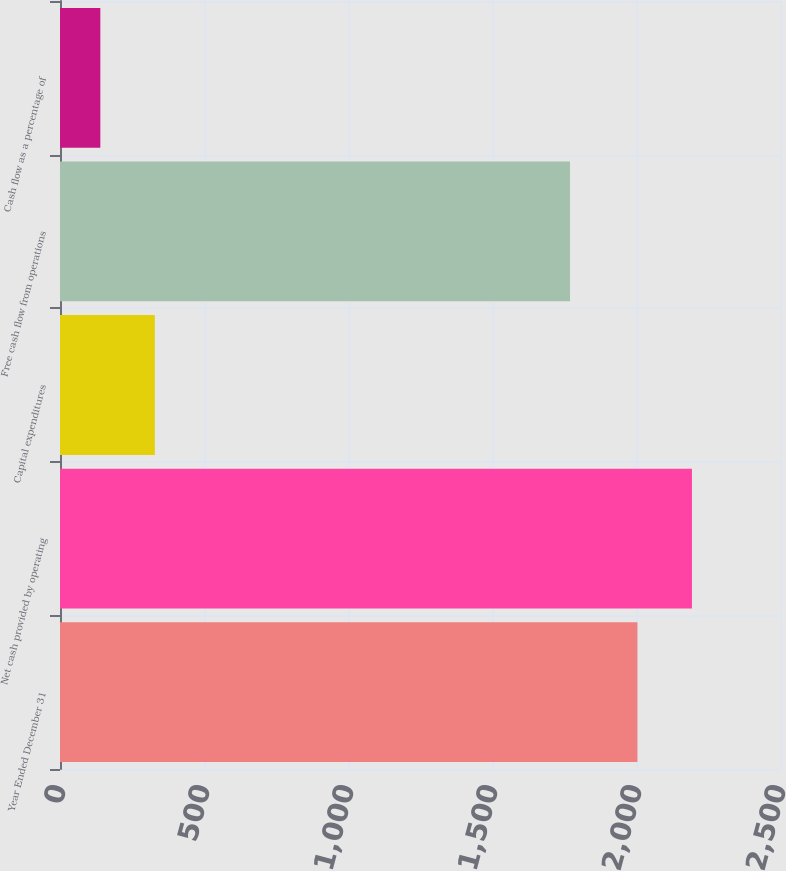<chart> <loc_0><loc_0><loc_500><loc_500><bar_chart><fcel>Year Ended December 31<fcel>Net cash provided by operating<fcel>Capital expenditures<fcel>Free cash flow from operations<fcel>Cash flow as a percentage of<nl><fcel>2005<fcel>2194.3<fcel>329.3<fcel>1771<fcel>140<nl></chart> 